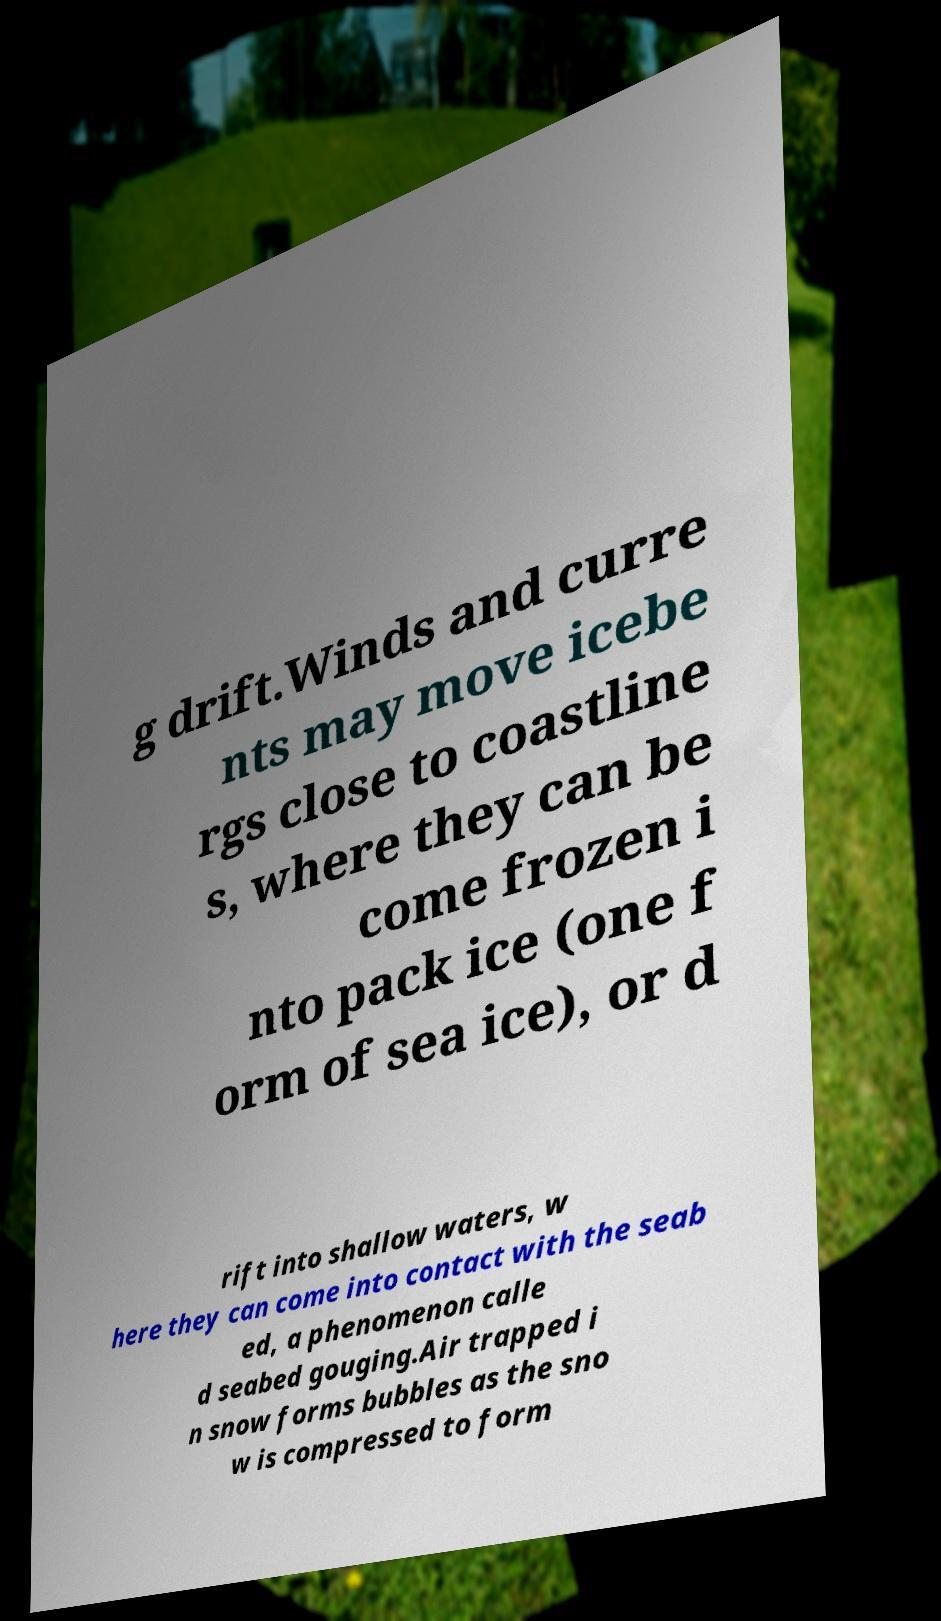There's text embedded in this image that I need extracted. Can you transcribe it verbatim? g drift.Winds and curre nts may move icebe rgs close to coastline s, where they can be come frozen i nto pack ice (one f orm of sea ice), or d rift into shallow waters, w here they can come into contact with the seab ed, a phenomenon calle d seabed gouging.Air trapped i n snow forms bubbles as the sno w is compressed to form 